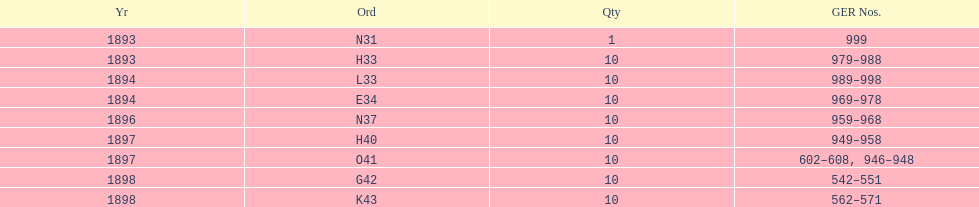What order is listed first at the top of the table? N31. 